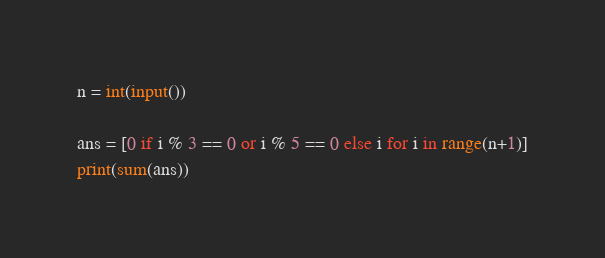<code> <loc_0><loc_0><loc_500><loc_500><_Python_>n = int(input())

ans = [0 if i % 3 == 0 or i % 5 == 0 else i for i in range(n+1)]
print(sum(ans))</code> 